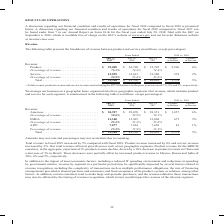From Cisco Systems's financial document, Which years does the table provide information about the company's revenue for each geographic segment? The document contains multiple relevant values: 2019, 2018, 2017. From the document: "vs. 2018 July 27, 2019 (1) July 28, 2018 July 29, 2017 Variance in Dollars Variance in Percent Revenue: Product . $ 39,005 $ 36,709 $ 35,705 $ 2,296 6..." Also, What was the revenue from Americas in 2019? According to the financial document, 30,927 (in millions). The relevant text states: "Dollars Variance in Percent Revenue: Americas . $ 30,927 $ 29,070 $ 28,351 $ 1,857 6% Percentage of revenue . 59.6% 58.9% 59.1% EMEA . 13,100 12,425 12,004..." Also, What was the percentage of total revenue was from Americas in 2018? According to the financial document, 58.9 (percentage). The relevant text states: "$ 28,351 $ 1,857 6% Percentage of revenue . 59.6% 58.9% 59.1% EMEA . 13,100 12,425 12,004 675 5% Percentage of revenue . 25.2% 25.2% 25.0% APJC. . 7,877 7..." Also, can you calculate: What was the change for revenue from EMEA between 2017 and 2018? Based on the calculation: 12,425-12,004, the result is 421 (in millions). This is based on the information: "tage of revenue . 59.6% 58.9% 59.1% EMEA . 13,100 12,425 12,004 675 5% Percentage of revenue . 25.2% 25.2% 25.0% APJC. . 7,877 7,834 7,650 43 1% Percentage revenue . 59.6% 58.9% 59.1% EMEA . 13,100 12..." The key data points involved are: 12,004, 12,425. Also, How many years did total revenue from all segments exceed $50,000 million? Based on the analysis, there are 1 instances. The counting process: 2019. Also, can you calculate: What was the percentage change in the revenue from APJC between 2018 and 2019? To answer this question, I need to perform calculations using the financial data. The calculation is: (7,877-7,834)/7,834, which equals 0.55 (percentage). This is based on the information: "Percentage of revenue . 25.2% 25.2% 25.0% APJC. . 7,877 7,834 7,650 43 1% Percentage of revenue . 15.2% 15.9% 15.9% Total . $ 51,904 $ 49,330 $ 48,005 $ 2, tage of revenue . 25.2% 25.2% 25.0% APJC. . ..." The key data points involved are: 7,834, 7,877. 